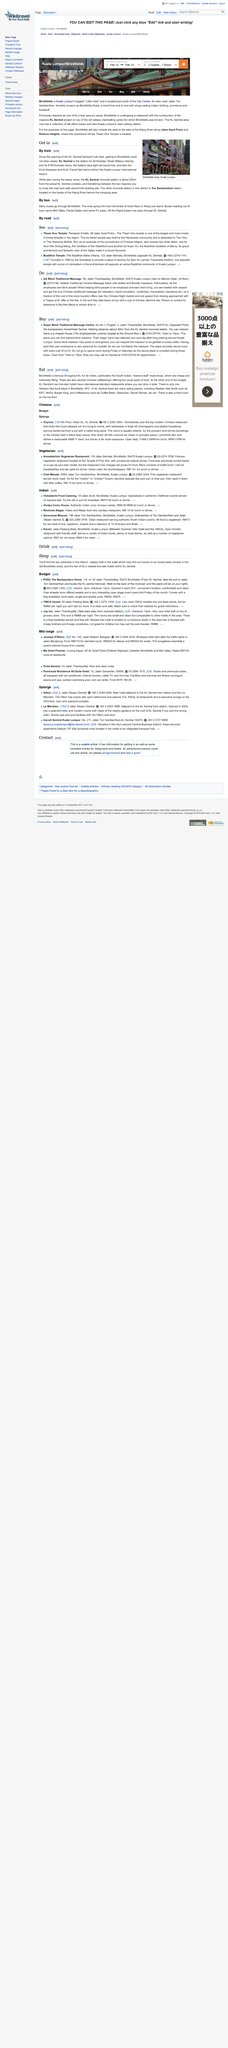Draw attention to some important aspects in this diagram. The Jalan Tun Sambanthan road is lined with shops that sell a variety of Indian clothing, provisions, and foodstuffs, catering to the needs of the local Indian community. To travel from KL Sentral train station to the KL Sentral monorail station, one must first cross the road and then walk around the monorail station building. The Jalan Tun Sambanthan road was previously known as Brickfields Road. The distance from KL Sentral train station to KL Sentral monorail station is approximately 200 meters. Kuala Lumpur Sentral is the train station used for intercity travel with Keretapi Tanah Melayu. This station is commonly referred to as KL Sentral. 